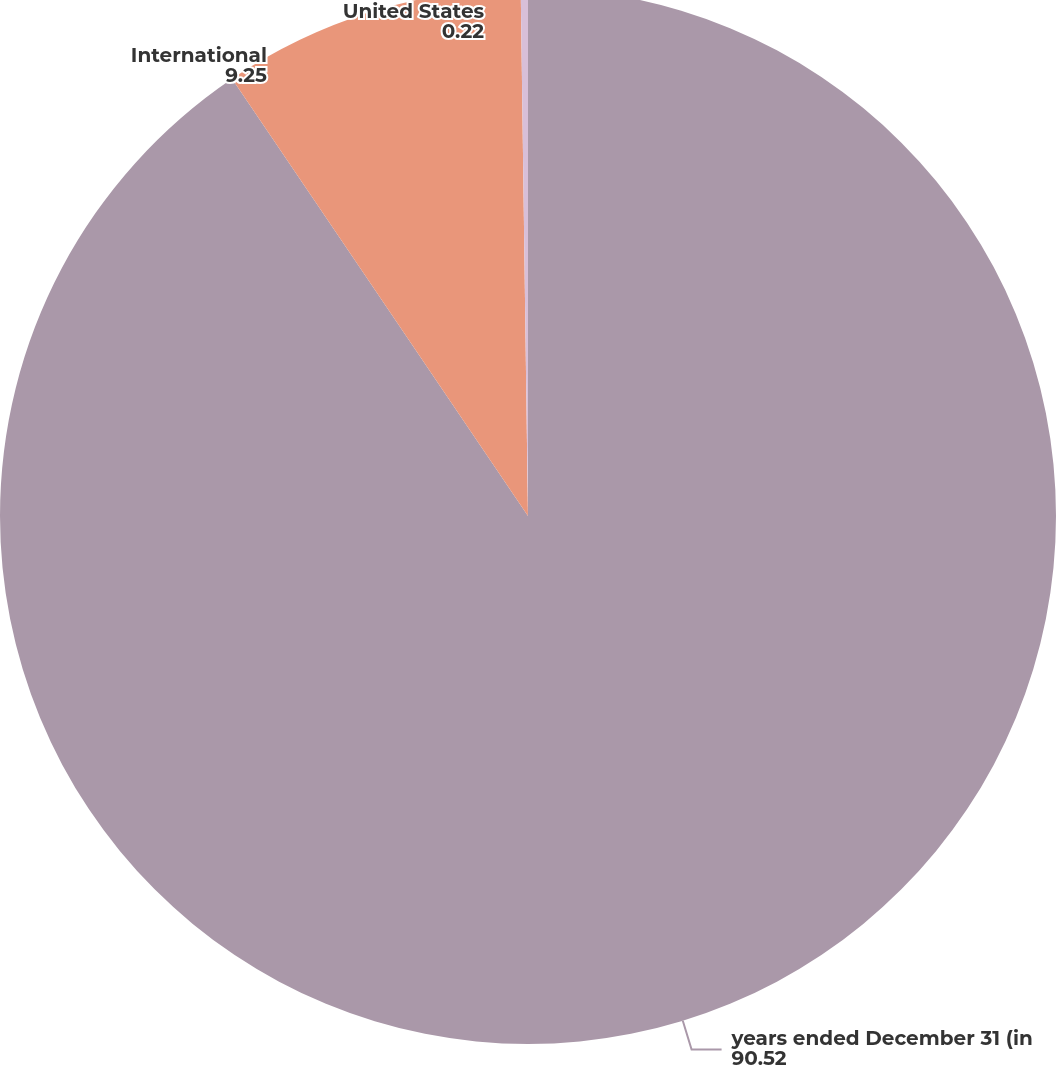Convert chart. <chart><loc_0><loc_0><loc_500><loc_500><pie_chart><fcel>years ended December 31 (in<fcel>International<fcel>United States<nl><fcel>90.52%<fcel>9.25%<fcel>0.22%<nl></chart> 